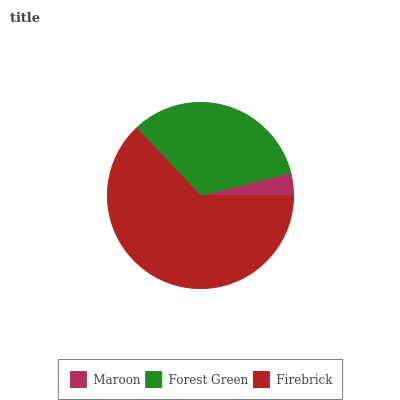Is Maroon the minimum?
Answer yes or no. Yes. Is Firebrick the maximum?
Answer yes or no. Yes. Is Forest Green the minimum?
Answer yes or no. No. Is Forest Green the maximum?
Answer yes or no. No. Is Forest Green greater than Maroon?
Answer yes or no. Yes. Is Maroon less than Forest Green?
Answer yes or no. Yes. Is Maroon greater than Forest Green?
Answer yes or no. No. Is Forest Green less than Maroon?
Answer yes or no. No. Is Forest Green the high median?
Answer yes or no. Yes. Is Forest Green the low median?
Answer yes or no. Yes. Is Firebrick the high median?
Answer yes or no. No. Is Firebrick the low median?
Answer yes or no. No. 